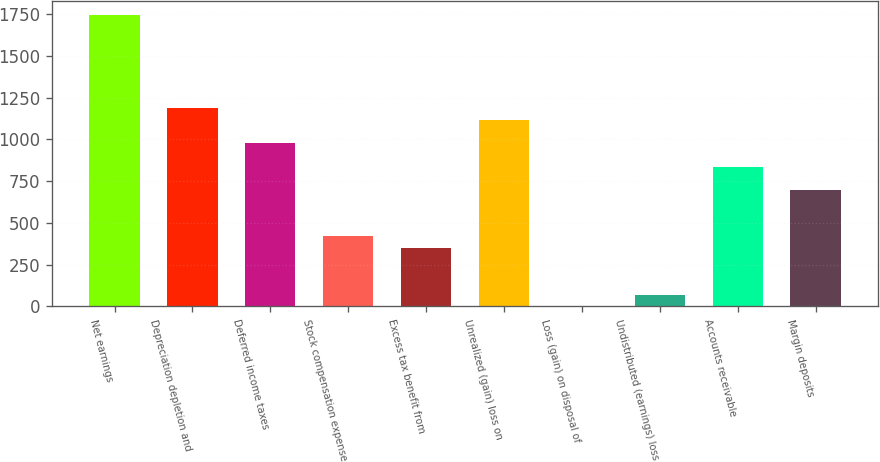Convert chart to OTSL. <chart><loc_0><loc_0><loc_500><loc_500><bar_chart><fcel>Net earnings<fcel>Depreciation depletion and<fcel>Deferred income taxes<fcel>Stock compensation expense<fcel>Excess tax benefit from<fcel>Unrealized (gain) loss on<fcel>Loss (gain) on disposal of<fcel>Undistributed (earnings) loss<fcel>Accounts receivable<fcel>Margin deposits<nl><fcel>1741.7<fcel>1184.58<fcel>975.66<fcel>418.54<fcel>348.9<fcel>1114.94<fcel>0.7<fcel>70.34<fcel>836.38<fcel>697.1<nl></chart> 